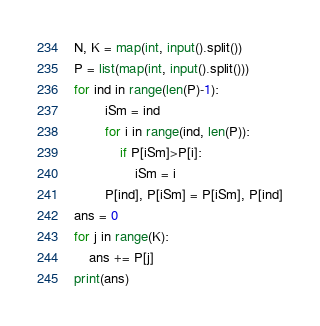<code> <loc_0><loc_0><loc_500><loc_500><_Python_>N, K = map(int, input().split())
P = list(map(int, input().split()))
for ind in range(len(P)-1):
		iSm = ind
		for i in range(ind, len(P)):
			if P[iSm]>P[i]:
				iSm = i
		P[ind], P[iSm] = P[iSm], P[ind]
ans = 0
for j in range(K):
	ans += P[j]
print(ans)</code> 